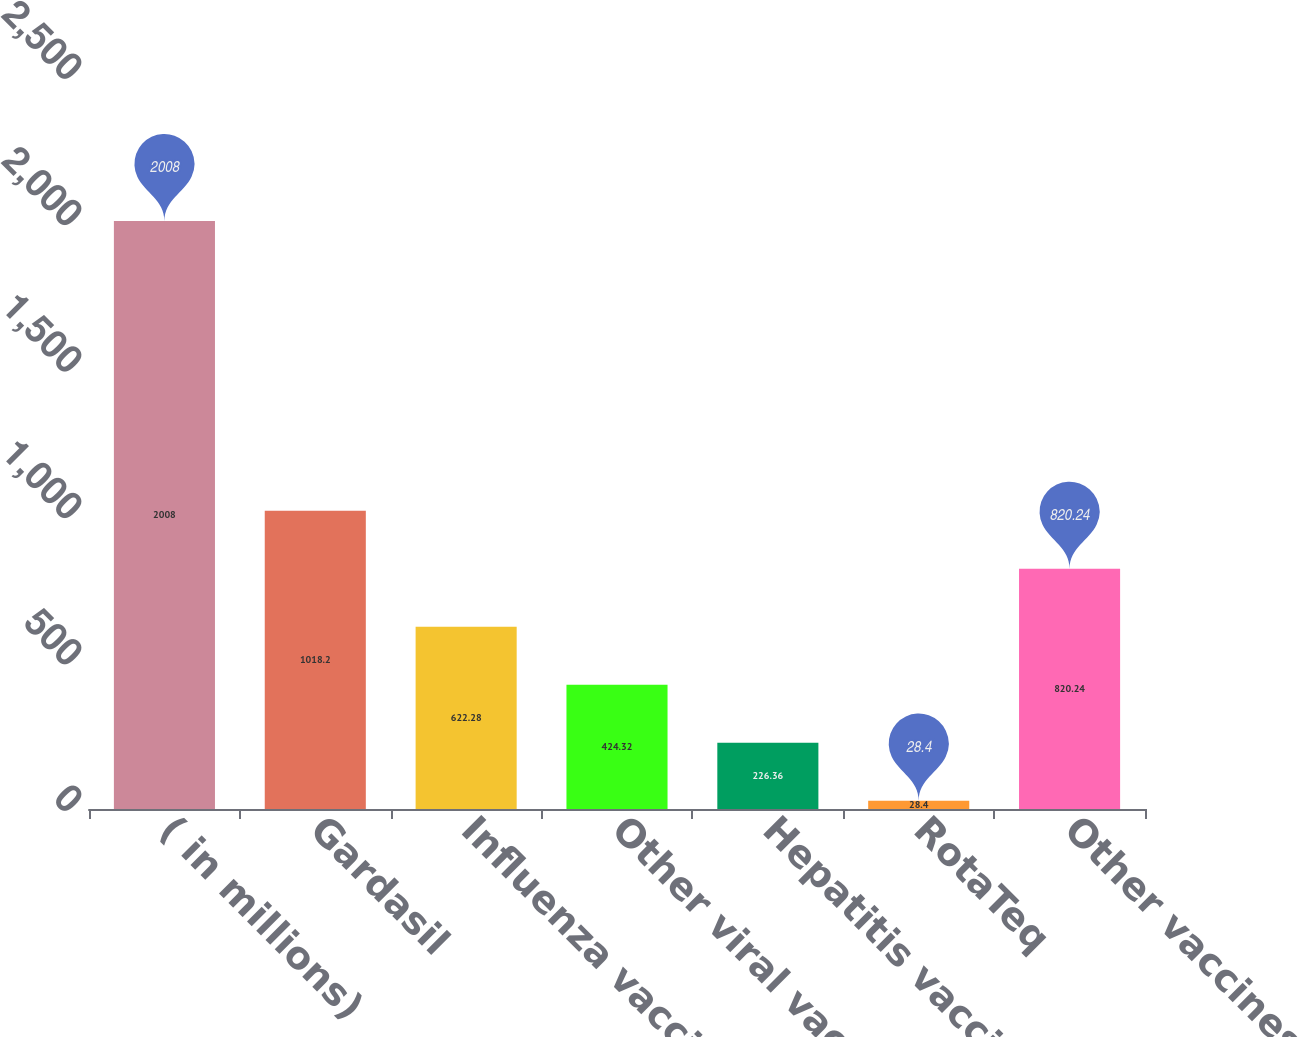<chart> <loc_0><loc_0><loc_500><loc_500><bar_chart><fcel>( in millions)<fcel>Gardasil<fcel>Influenza vaccines<fcel>Other viral vaccines<fcel>Hepatitis vaccines<fcel>RotaTeq<fcel>Other vaccines<nl><fcel>2008<fcel>1018.2<fcel>622.28<fcel>424.32<fcel>226.36<fcel>28.4<fcel>820.24<nl></chart> 